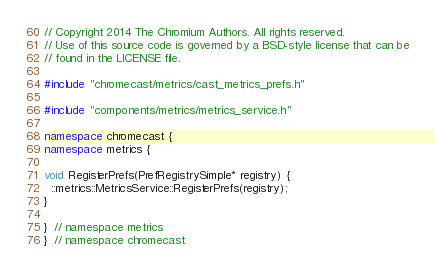Convert code to text. <code><loc_0><loc_0><loc_500><loc_500><_C++_>// Copyright 2014 The Chromium Authors. All rights reserved.
// Use of this source code is governed by a BSD-style license that can be
// found in the LICENSE file.

#include "chromecast/metrics/cast_metrics_prefs.h"

#include "components/metrics/metrics_service.h"

namespace chromecast {
namespace metrics {

void RegisterPrefs(PrefRegistrySimple* registry) {
  ::metrics::MetricsService::RegisterPrefs(registry);
}

}  // namespace metrics
}  // namespace chromecast
</code> 